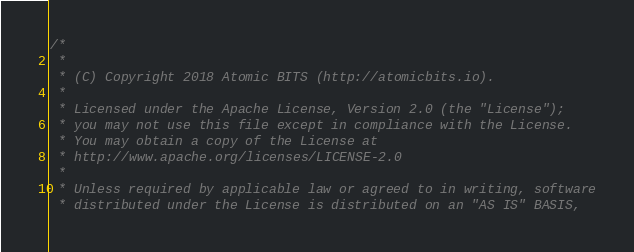<code> <loc_0><loc_0><loc_500><loc_500><_Scala_>/*
 *
 * (C) Copyright 2018 Atomic BITS (http://atomicbits.io).
 *
 * Licensed under the Apache License, Version 2.0 (the "License");
 * you may not use this file except in compliance with the License.
 * You may obtain a copy of the License at
 * http://www.apache.org/licenses/LICENSE-2.0
 *
 * Unless required by applicable law or agreed to in writing, software
 * distributed under the License is distributed on an "AS IS" BASIS,</code> 